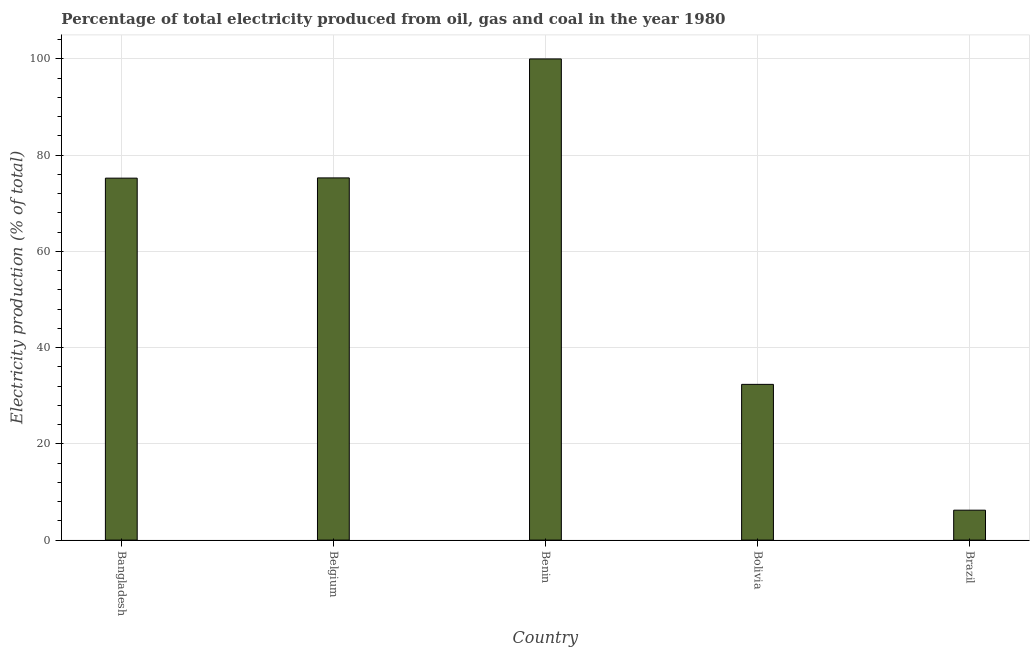Does the graph contain grids?
Your response must be concise. Yes. What is the title of the graph?
Your answer should be compact. Percentage of total electricity produced from oil, gas and coal in the year 1980. What is the label or title of the X-axis?
Provide a short and direct response. Country. What is the label or title of the Y-axis?
Give a very brief answer. Electricity production (% of total). What is the electricity production in Belgium?
Offer a very short reply. 75.27. Across all countries, what is the maximum electricity production?
Offer a very short reply. 100. Across all countries, what is the minimum electricity production?
Keep it short and to the point. 6.22. In which country was the electricity production maximum?
Offer a very short reply. Benin. In which country was the electricity production minimum?
Your response must be concise. Brazil. What is the sum of the electricity production?
Your answer should be very brief. 289.08. What is the difference between the electricity production in Belgium and Bolivia?
Offer a very short reply. 42.91. What is the average electricity production per country?
Your answer should be very brief. 57.82. What is the median electricity production?
Offer a terse response. 75.22. In how many countries, is the electricity production greater than 12 %?
Give a very brief answer. 4. What is the ratio of the electricity production in Bangladesh to that in Belgium?
Provide a short and direct response. 1. Is the difference between the electricity production in Bangladesh and Brazil greater than the difference between any two countries?
Provide a succinct answer. No. What is the difference between the highest and the second highest electricity production?
Ensure brevity in your answer.  24.73. Is the sum of the electricity production in Bangladesh and Belgium greater than the maximum electricity production across all countries?
Ensure brevity in your answer.  Yes. What is the difference between the highest and the lowest electricity production?
Your answer should be compact. 93.78. In how many countries, is the electricity production greater than the average electricity production taken over all countries?
Your answer should be very brief. 3. How many bars are there?
Offer a very short reply. 5. Are all the bars in the graph horizontal?
Offer a terse response. No. What is the difference between two consecutive major ticks on the Y-axis?
Give a very brief answer. 20. Are the values on the major ticks of Y-axis written in scientific E-notation?
Your answer should be very brief. No. What is the Electricity production (% of total) of Bangladesh?
Offer a very short reply. 75.22. What is the Electricity production (% of total) in Belgium?
Make the answer very short. 75.27. What is the Electricity production (% of total) in Bolivia?
Make the answer very short. 32.37. What is the Electricity production (% of total) of Brazil?
Make the answer very short. 6.22. What is the difference between the Electricity production (% of total) in Bangladesh and Belgium?
Offer a terse response. -0.05. What is the difference between the Electricity production (% of total) in Bangladesh and Benin?
Your answer should be very brief. -24.78. What is the difference between the Electricity production (% of total) in Bangladesh and Bolivia?
Provide a short and direct response. 42.86. What is the difference between the Electricity production (% of total) in Bangladesh and Brazil?
Give a very brief answer. 69. What is the difference between the Electricity production (% of total) in Belgium and Benin?
Provide a succinct answer. -24.73. What is the difference between the Electricity production (% of total) in Belgium and Bolivia?
Ensure brevity in your answer.  42.91. What is the difference between the Electricity production (% of total) in Belgium and Brazil?
Offer a terse response. 69.06. What is the difference between the Electricity production (% of total) in Benin and Bolivia?
Provide a short and direct response. 67.63. What is the difference between the Electricity production (% of total) in Benin and Brazil?
Your answer should be compact. 93.78. What is the difference between the Electricity production (% of total) in Bolivia and Brazil?
Ensure brevity in your answer.  26.15. What is the ratio of the Electricity production (% of total) in Bangladesh to that in Benin?
Your answer should be very brief. 0.75. What is the ratio of the Electricity production (% of total) in Bangladesh to that in Bolivia?
Keep it short and to the point. 2.32. What is the ratio of the Electricity production (% of total) in Bangladesh to that in Brazil?
Ensure brevity in your answer.  12.1. What is the ratio of the Electricity production (% of total) in Belgium to that in Benin?
Provide a succinct answer. 0.75. What is the ratio of the Electricity production (% of total) in Belgium to that in Bolivia?
Offer a terse response. 2.33. What is the ratio of the Electricity production (% of total) in Belgium to that in Brazil?
Offer a terse response. 12.1. What is the ratio of the Electricity production (% of total) in Benin to that in Bolivia?
Provide a succinct answer. 3.09. What is the ratio of the Electricity production (% of total) in Benin to that in Brazil?
Give a very brief answer. 16.08. What is the ratio of the Electricity production (% of total) in Bolivia to that in Brazil?
Provide a short and direct response. 5.2. 